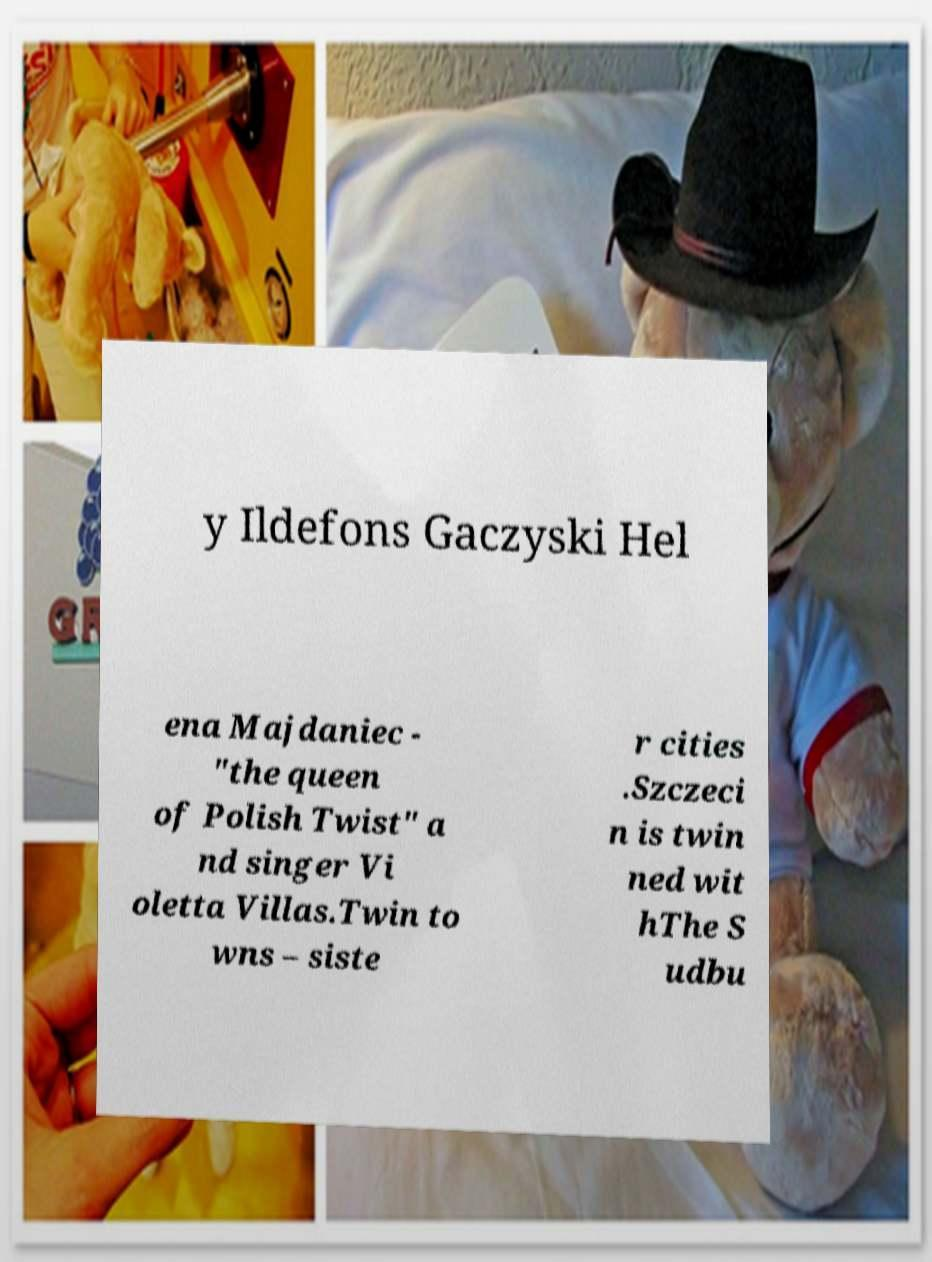Please identify and transcribe the text found in this image. y Ildefons Gaczyski Hel ena Majdaniec - "the queen of Polish Twist" a nd singer Vi oletta Villas.Twin to wns – siste r cities .Szczeci n is twin ned wit hThe S udbu 